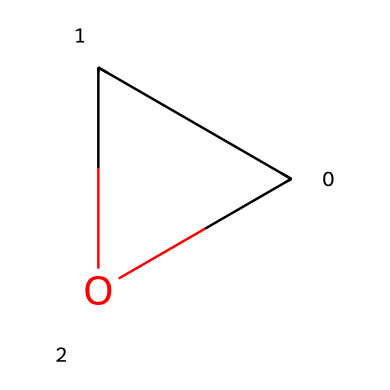What is the molecular formula of this compound? By analyzing the chemical structure represented by the SMILES notation C1CO1, we can identify the atoms present. The compound has one carbon atom (C) and two oxygen atoms (O) arranged in a cyclic format. Therefore, the molecular formula is C2H4O.
Answer: C2H4O How many rings are present in the structure? The SMILES notation includes 'C1' and 'O1', indicating the start and end of a ring. This means there is one cyclic structure formed by the carbon and oxygen atoms.
Answer: one What type of bonding exists in this compound? Inspecting the chemical structure, we see that the atoms are connected by single bonds with no double or triple bonds indicated in the SMILES. This infers that it primarily involves single covalent bonding.
Answer: single covalent bonds What key element affects the reactivity of this compound? The presence of the oxygen atom in the cyclic structure can influence the reactivity due to its electronegativity and ability to engage in nucleophilic reactions. Therefore, we attribute the reactivity primarily to the oxygen atom.
Answer: oxygen Does this compound belong to a specific category of aliphatic compounds? Ethylene oxide, represented by the given structure, is classified as an epoxide, which is a type of cyclic ether. Thus, it fits within a unique subgroup of aliphatic compounds known for their three-membered ring structure.
Answer: epoxide What is the total number of hydrogen atoms in this compound? By analyzing the molecular formula C2H4O, we count the number of hydrogen atoms directly. Therefore, there are four hydrogen atoms connected to the carbon and oxygen atoms in the structure.
Answer: four 